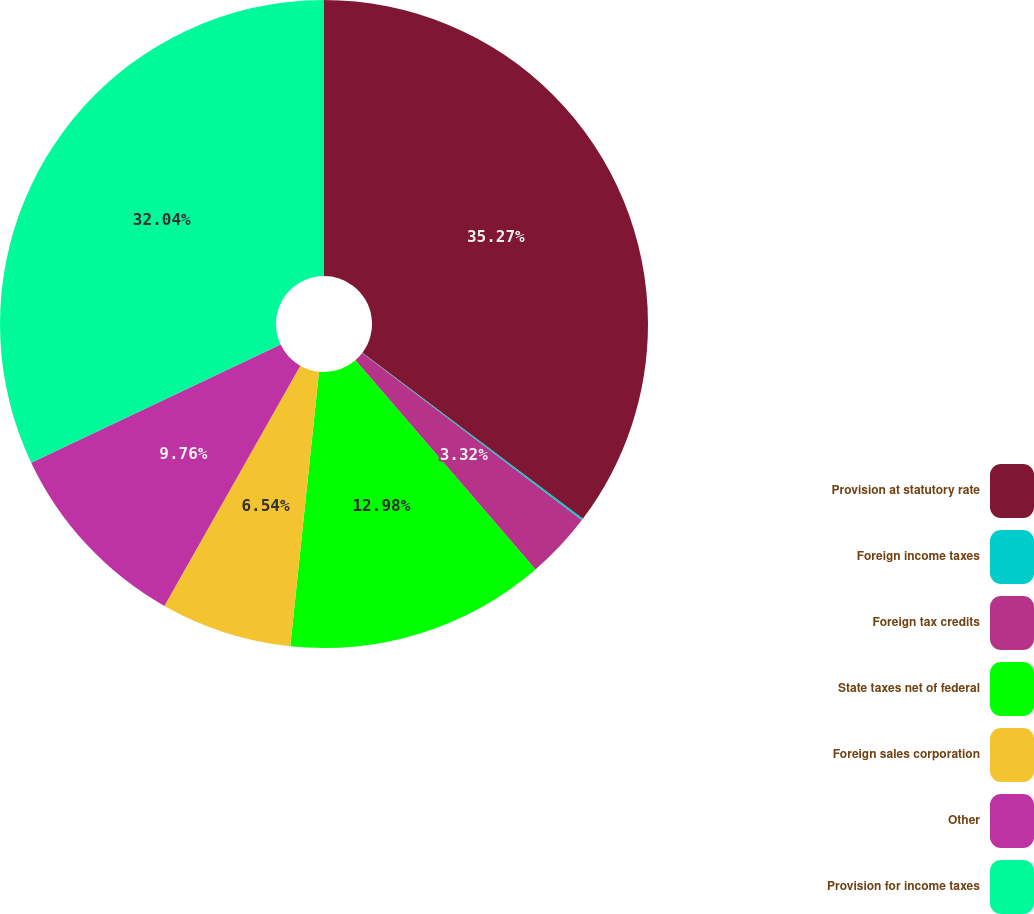<chart> <loc_0><loc_0><loc_500><loc_500><pie_chart><fcel>Provision at statutory rate<fcel>Foreign income taxes<fcel>Foreign tax credits<fcel>State taxes net of federal<fcel>Foreign sales corporation<fcel>Other<fcel>Provision for income taxes<nl><fcel>35.27%<fcel>0.09%<fcel>3.32%<fcel>12.98%<fcel>6.54%<fcel>9.76%<fcel>32.04%<nl></chart> 